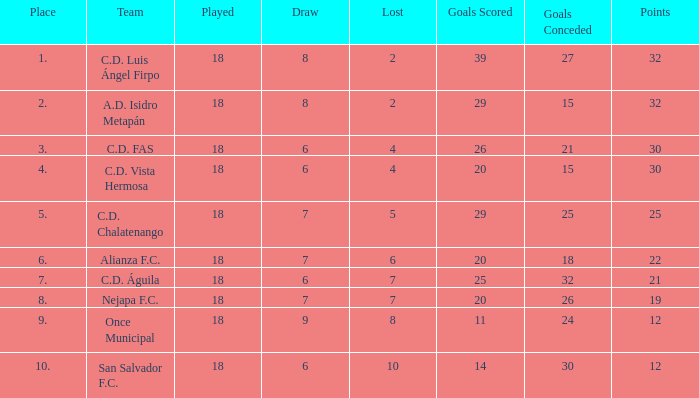What is the lowest played with a lost bigger than 10? None. 